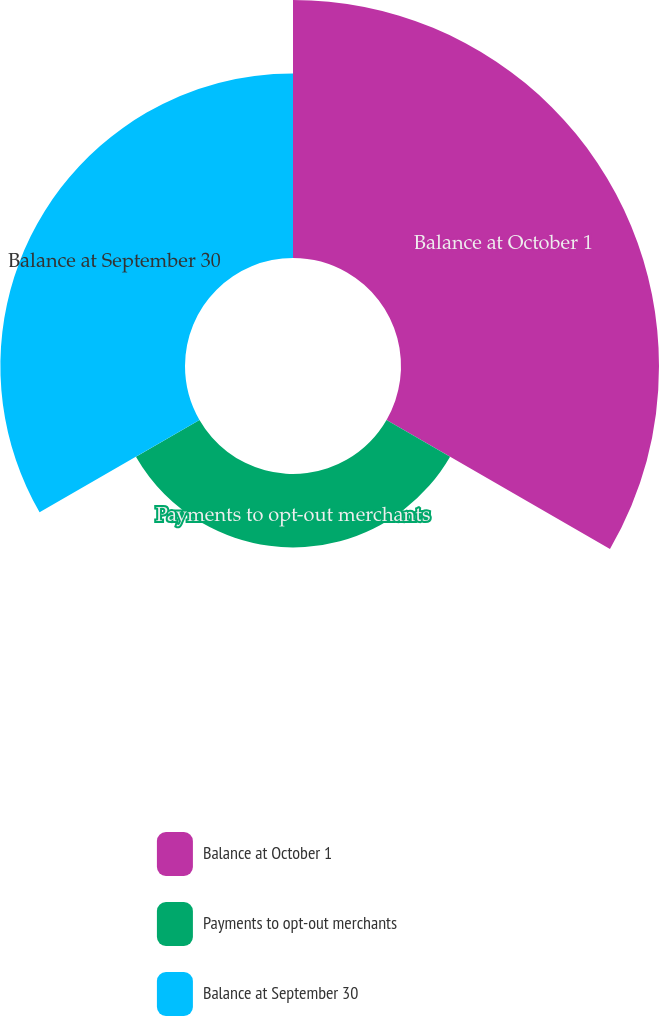Convert chart. <chart><loc_0><loc_0><loc_500><loc_500><pie_chart><fcel>Balance at October 1<fcel>Payments to opt-out merchants<fcel>Balance at September 30<nl><fcel>50.0%<fcel>14.22%<fcel>35.78%<nl></chart> 